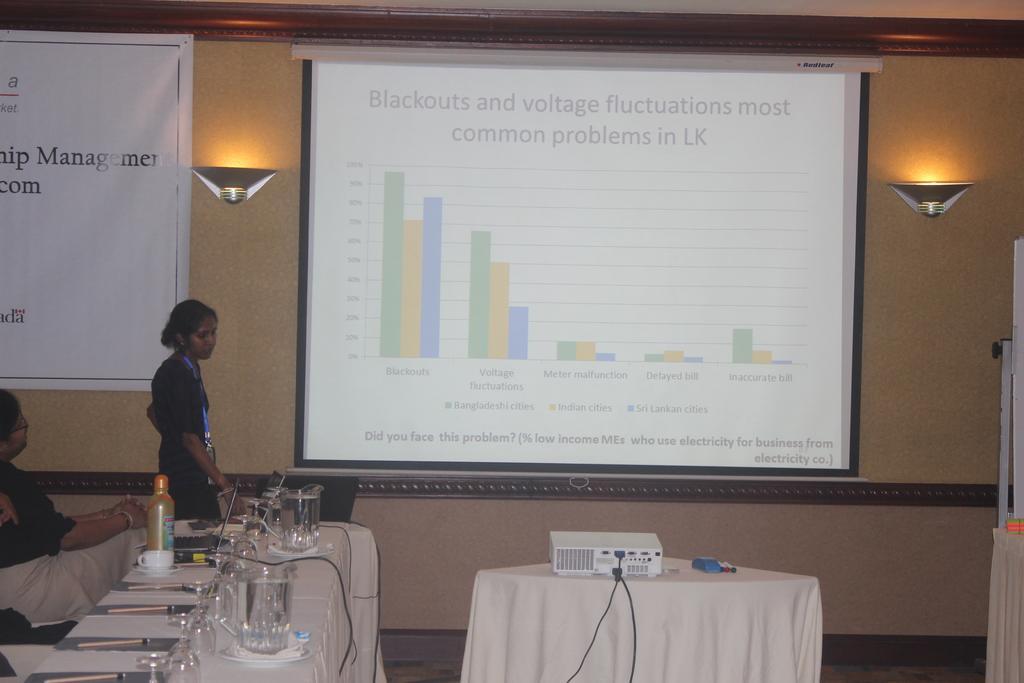Describe this image in one or two sentences. In this picture we can see a projector, wires, pens, white cloth and a blue object on a table. There is water in jugs. We can see a few glasses, papers, pen, cup, bottle and other objects on the table on the left side. There is a person sitting on a chair. A woman is standing on the left side. A laptop is visible on the table. We can see a banner on the left side. There is a projector screen. 